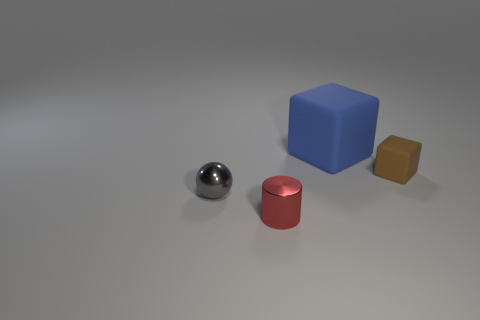Add 3 cyan blocks. How many objects exist? 7 Subtract all spheres. How many objects are left? 3 Subtract all gray metallic spheres. Subtract all large metal cylinders. How many objects are left? 3 Add 1 blocks. How many blocks are left? 3 Add 2 red balls. How many red balls exist? 2 Subtract 0 gray cubes. How many objects are left? 4 